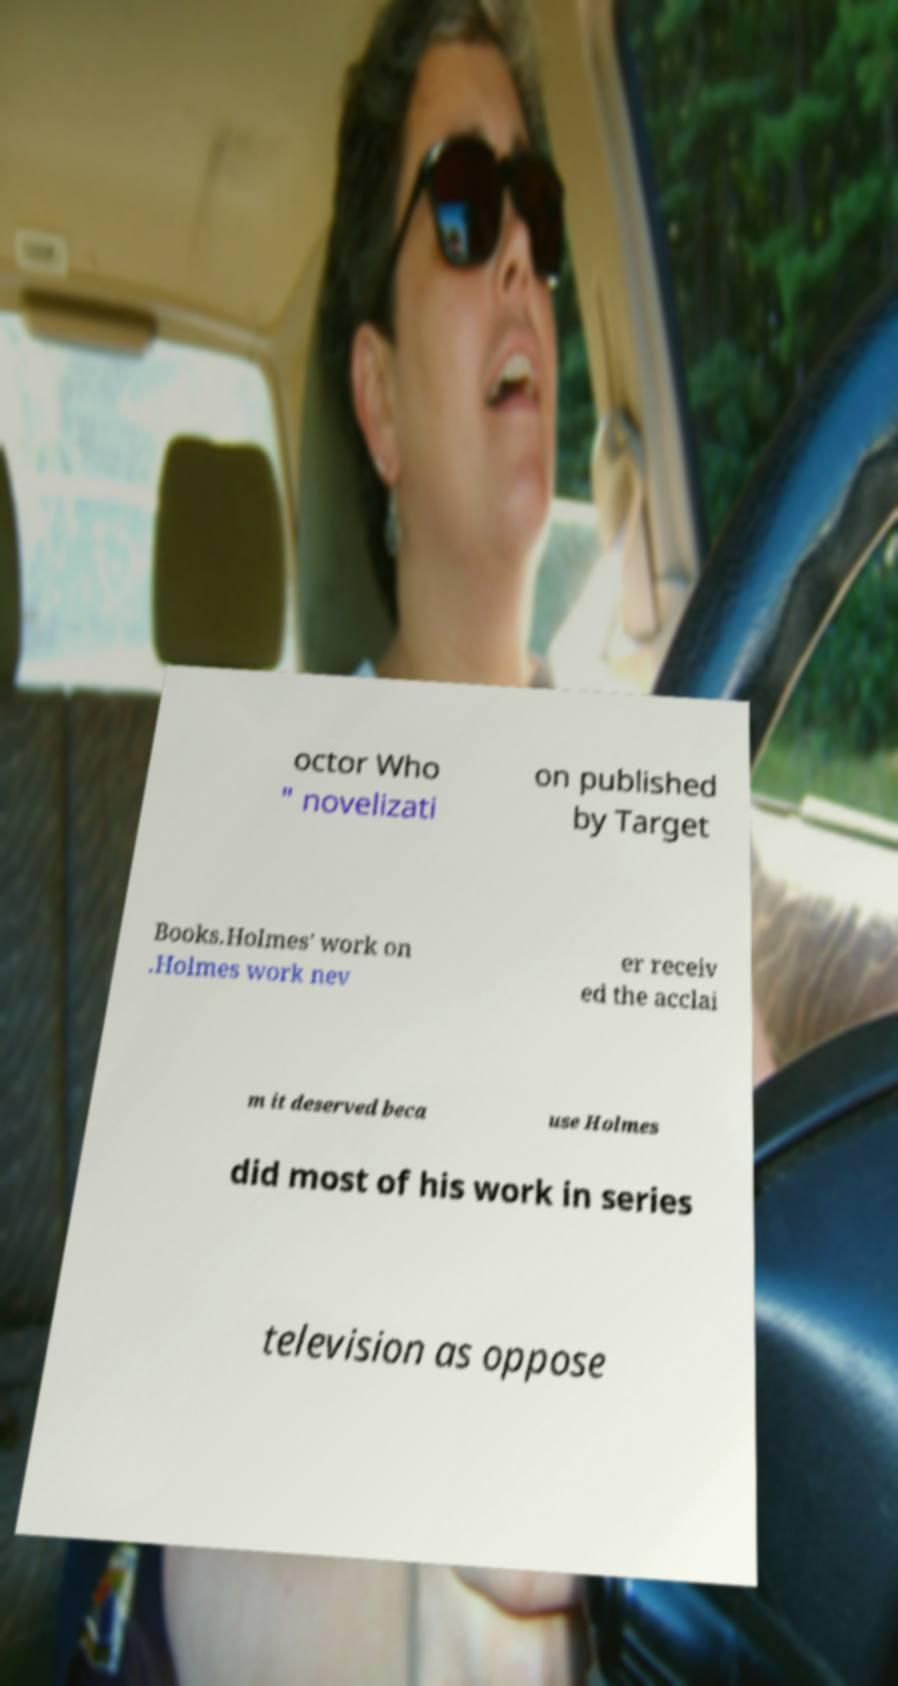Please identify and transcribe the text found in this image. octor Who " novelizati on published by Target Books.Holmes' work on .Holmes work nev er receiv ed the acclai m it deserved beca use Holmes did most of his work in series television as oppose 